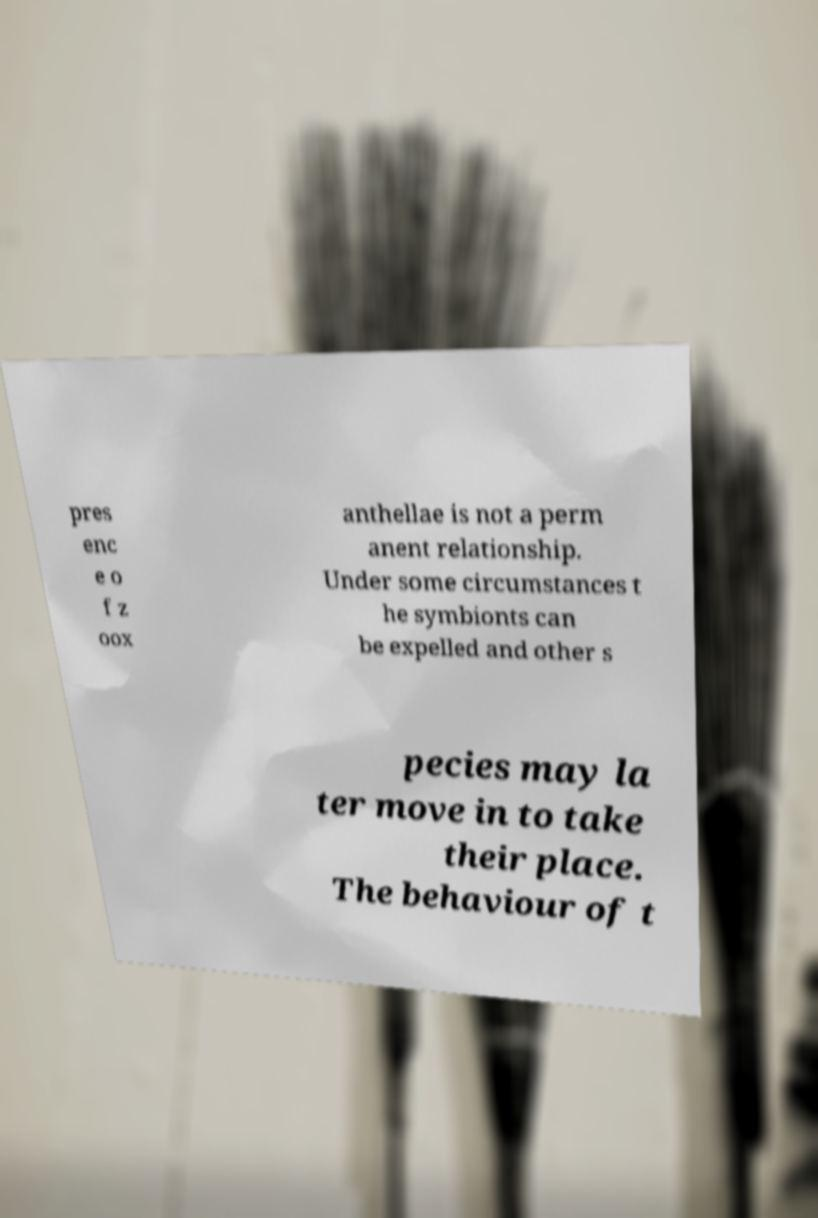Can you accurately transcribe the text from the provided image for me? pres enc e o f z oox anthellae is not a perm anent relationship. Under some circumstances t he symbionts can be expelled and other s pecies may la ter move in to take their place. The behaviour of t 